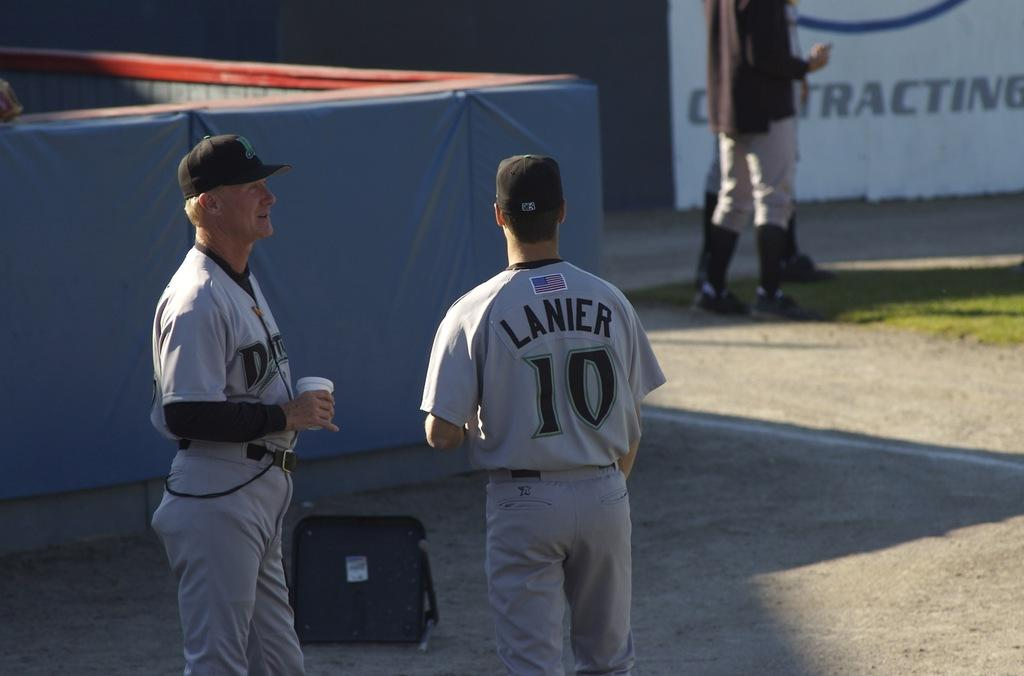<image>
Create a compact narrative representing the image presented. Two baseball players, including one named Lanier wearing number 10, stand on a field. 